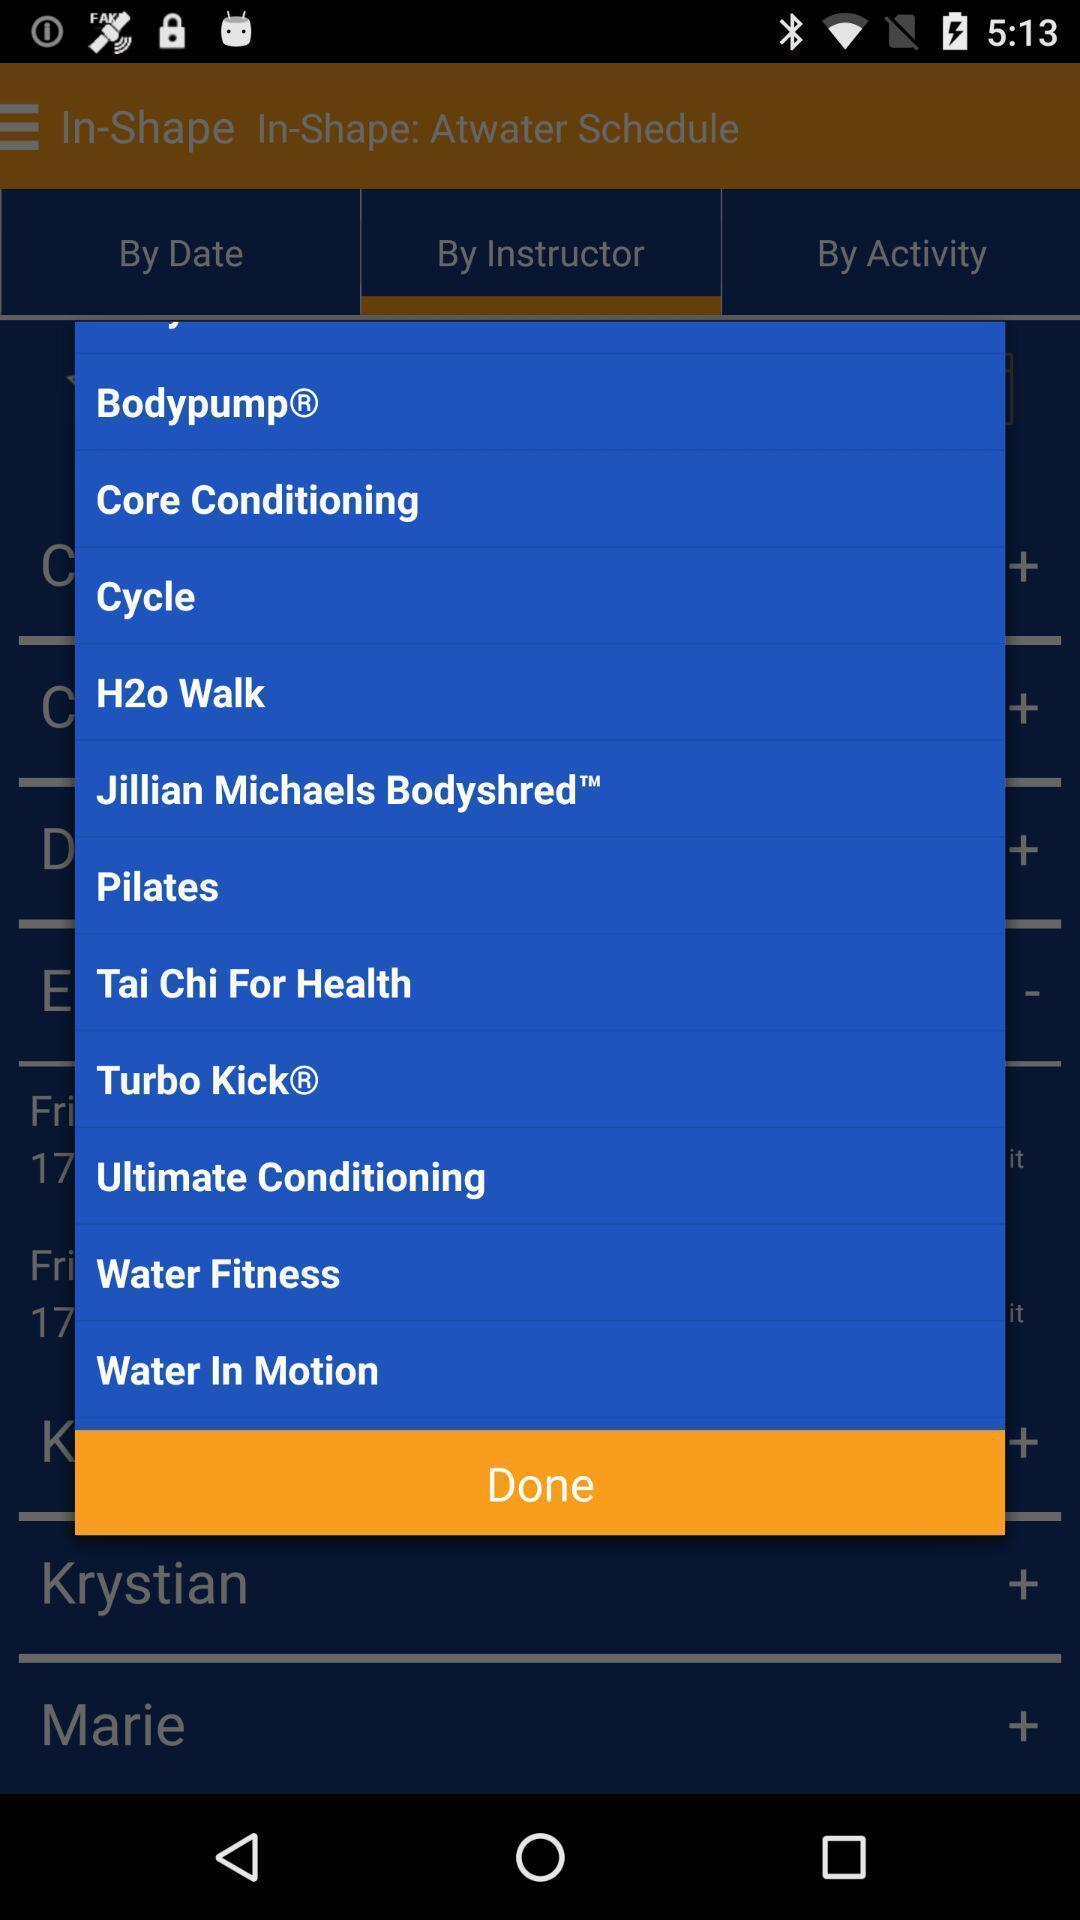What details can you identify in this image? Pop-up with list of different exercises. 